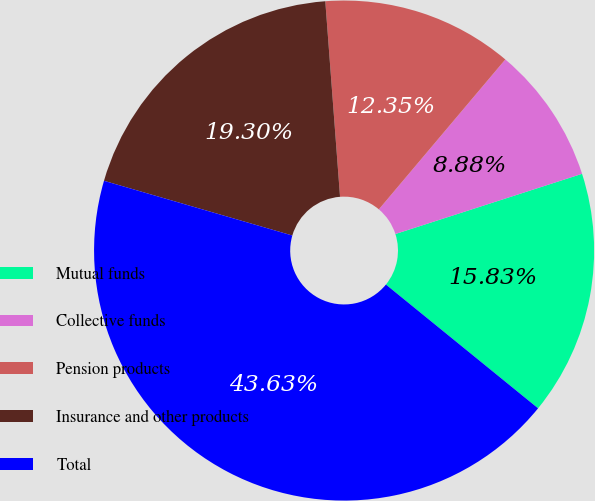<chart> <loc_0><loc_0><loc_500><loc_500><pie_chart><fcel>Mutual funds<fcel>Collective funds<fcel>Pension products<fcel>Insurance and other products<fcel>Total<nl><fcel>15.83%<fcel>8.88%<fcel>12.35%<fcel>19.3%<fcel>43.63%<nl></chart> 